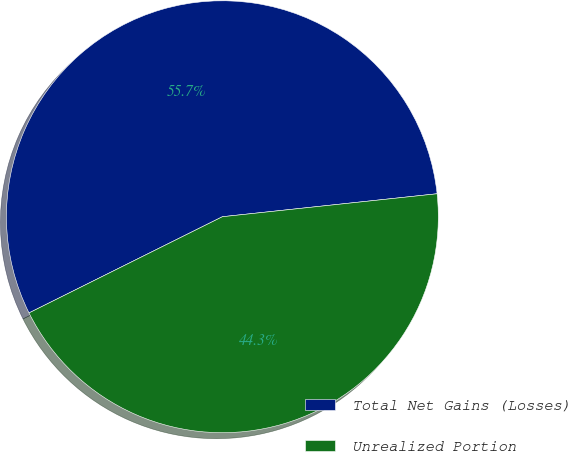<chart> <loc_0><loc_0><loc_500><loc_500><pie_chart><fcel>Total Net Gains (Losses)<fcel>Unrealized Portion<nl><fcel>55.65%<fcel>44.35%<nl></chart> 